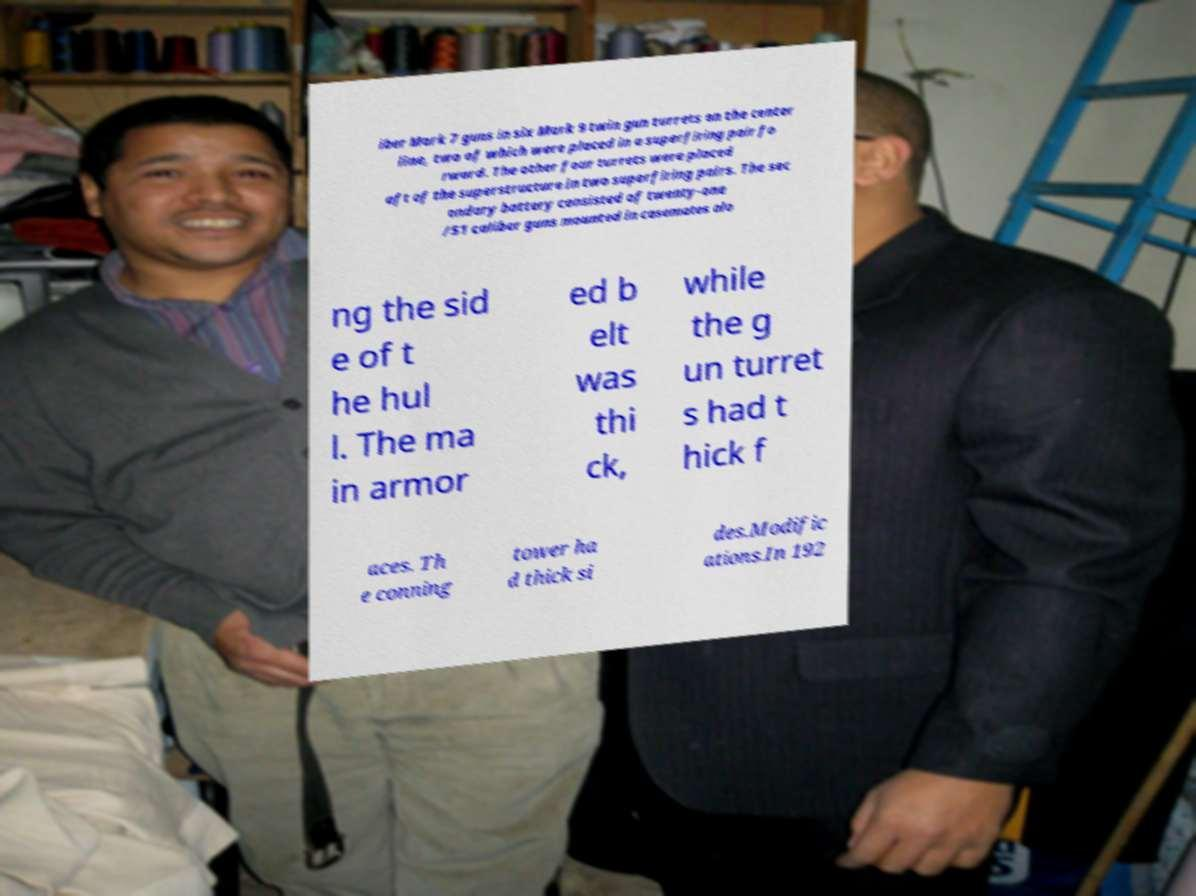For documentation purposes, I need the text within this image transcribed. Could you provide that? iber Mark 7 guns in six Mark 9 twin gun turrets on the center line, two of which were placed in a superfiring pair fo rward. The other four turrets were placed aft of the superstructure in two superfiring pairs. The sec ondary battery consisted of twenty-one /51 caliber guns mounted in casemates alo ng the sid e of t he hul l. The ma in armor ed b elt was thi ck, while the g un turret s had t hick f aces. Th e conning tower ha d thick si des.Modific ations.In 192 